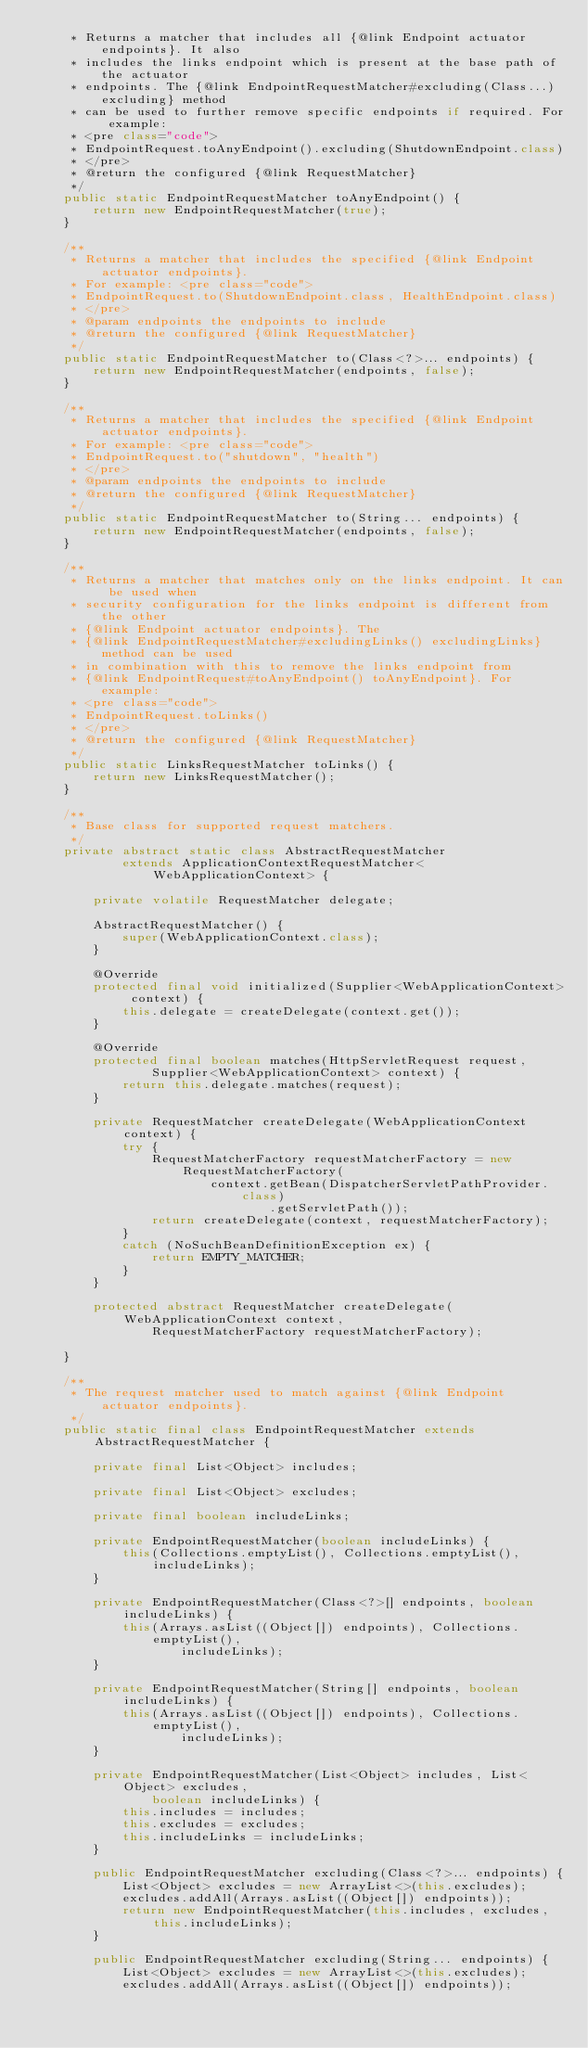<code> <loc_0><loc_0><loc_500><loc_500><_Java_>	 * Returns a matcher that includes all {@link Endpoint actuator endpoints}. It also
	 * includes the links endpoint which is present at the base path of the actuator
	 * endpoints. The {@link EndpointRequestMatcher#excluding(Class...) excluding} method
	 * can be used to further remove specific endpoints if required. For example:
	 * <pre class="code">
	 * EndpointRequest.toAnyEndpoint().excluding(ShutdownEndpoint.class)
	 * </pre>
	 * @return the configured {@link RequestMatcher}
	 */
	public static EndpointRequestMatcher toAnyEndpoint() {
		return new EndpointRequestMatcher(true);
	}

	/**
	 * Returns a matcher that includes the specified {@link Endpoint actuator endpoints}.
	 * For example: <pre class="code">
	 * EndpointRequest.to(ShutdownEndpoint.class, HealthEndpoint.class)
	 * </pre>
	 * @param endpoints the endpoints to include
	 * @return the configured {@link RequestMatcher}
	 */
	public static EndpointRequestMatcher to(Class<?>... endpoints) {
		return new EndpointRequestMatcher(endpoints, false);
	}

	/**
	 * Returns a matcher that includes the specified {@link Endpoint actuator endpoints}.
	 * For example: <pre class="code">
	 * EndpointRequest.to("shutdown", "health")
	 * </pre>
	 * @param endpoints the endpoints to include
	 * @return the configured {@link RequestMatcher}
	 */
	public static EndpointRequestMatcher to(String... endpoints) {
		return new EndpointRequestMatcher(endpoints, false);
	}

	/**
	 * Returns a matcher that matches only on the links endpoint. It can be used when
	 * security configuration for the links endpoint is different from the other
	 * {@link Endpoint actuator endpoints}. The
	 * {@link EndpointRequestMatcher#excludingLinks() excludingLinks} method can be used
	 * in combination with this to remove the links endpoint from
	 * {@link EndpointRequest#toAnyEndpoint() toAnyEndpoint}. For example:
	 * <pre class="code">
	 * EndpointRequest.toLinks()
	 * </pre>
	 * @return the configured {@link RequestMatcher}
	 */
	public static LinksRequestMatcher toLinks() {
		return new LinksRequestMatcher();
	}

	/**
	 * Base class for supported request matchers.
	 */
	private abstract static class AbstractRequestMatcher
			extends ApplicationContextRequestMatcher<WebApplicationContext> {

		private volatile RequestMatcher delegate;

		AbstractRequestMatcher() {
			super(WebApplicationContext.class);
		}

		@Override
		protected final void initialized(Supplier<WebApplicationContext> context) {
			this.delegate = createDelegate(context.get());
		}

		@Override
		protected final boolean matches(HttpServletRequest request,
				Supplier<WebApplicationContext> context) {
			return this.delegate.matches(request);
		}

		private RequestMatcher createDelegate(WebApplicationContext context) {
			try {
				RequestMatcherFactory requestMatcherFactory = new RequestMatcherFactory(
						context.getBean(DispatcherServletPathProvider.class)
								.getServletPath());
				return createDelegate(context, requestMatcherFactory);
			}
			catch (NoSuchBeanDefinitionException ex) {
				return EMPTY_MATCHER;
			}
		}

		protected abstract RequestMatcher createDelegate(WebApplicationContext context,
				RequestMatcherFactory requestMatcherFactory);

	}

	/**
	 * The request matcher used to match against {@link Endpoint actuator endpoints}.
	 */
	public static final class EndpointRequestMatcher extends AbstractRequestMatcher {

		private final List<Object> includes;

		private final List<Object> excludes;

		private final boolean includeLinks;

		private EndpointRequestMatcher(boolean includeLinks) {
			this(Collections.emptyList(), Collections.emptyList(), includeLinks);
		}

		private EndpointRequestMatcher(Class<?>[] endpoints, boolean includeLinks) {
			this(Arrays.asList((Object[]) endpoints), Collections.emptyList(),
					includeLinks);
		}

		private EndpointRequestMatcher(String[] endpoints, boolean includeLinks) {
			this(Arrays.asList((Object[]) endpoints), Collections.emptyList(),
					includeLinks);
		}

		private EndpointRequestMatcher(List<Object> includes, List<Object> excludes,
				boolean includeLinks) {
			this.includes = includes;
			this.excludes = excludes;
			this.includeLinks = includeLinks;
		}

		public EndpointRequestMatcher excluding(Class<?>... endpoints) {
			List<Object> excludes = new ArrayList<>(this.excludes);
			excludes.addAll(Arrays.asList((Object[]) endpoints));
			return new EndpointRequestMatcher(this.includes, excludes, this.includeLinks);
		}

		public EndpointRequestMatcher excluding(String... endpoints) {
			List<Object> excludes = new ArrayList<>(this.excludes);
			excludes.addAll(Arrays.asList((Object[]) endpoints));</code> 